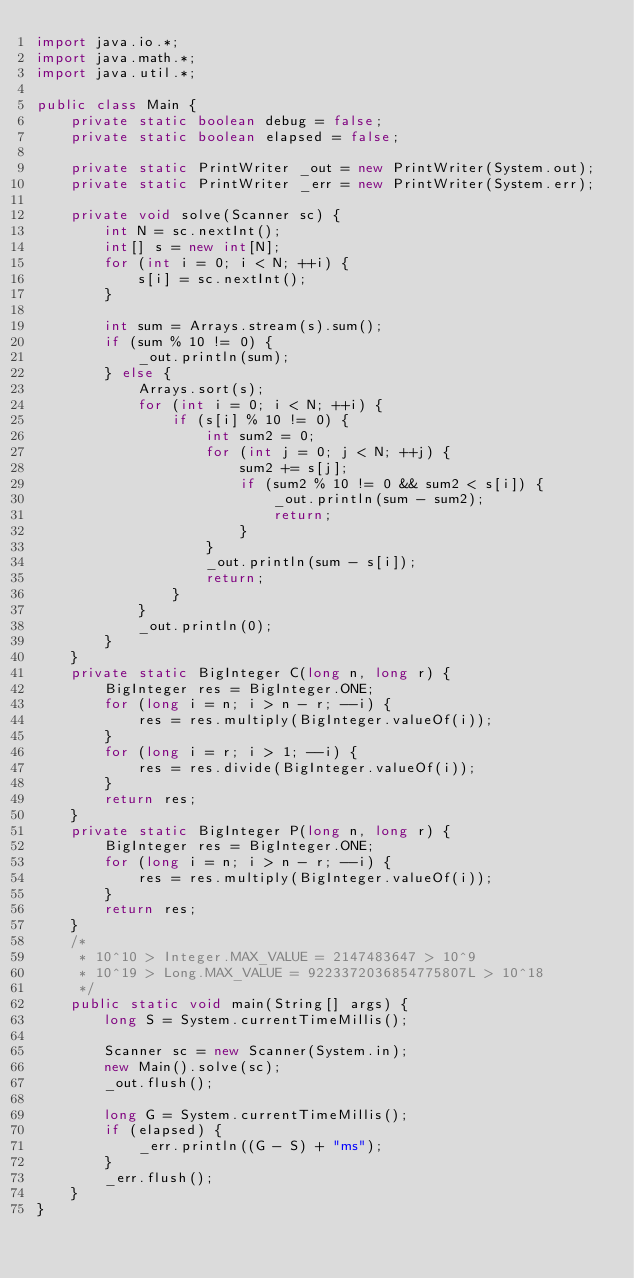<code> <loc_0><loc_0><loc_500><loc_500><_Java_>import java.io.*;
import java.math.*;
import java.util.*;

public class Main {
    private static boolean debug = false;
    private static boolean elapsed = false;

    private static PrintWriter _out = new PrintWriter(System.out);
    private static PrintWriter _err = new PrintWriter(System.err);

    private void solve(Scanner sc) {
        int N = sc.nextInt();
        int[] s = new int[N];
        for (int i = 0; i < N; ++i) {
            s[i] = sc.nextInt();
        }

        int sum = Arrays.stream(s).sum();
        if (sum % 10 != 0) {
            _out.println(sum);
        } else {
            Arrays.sort(s);
            for (int i = 0; i < N; ++i) {
                if (s[i] % 10 != 0) {
                    int sum2 = 0;
                    for (int j = 0; j < N; ++j) {
                        sum2 += s[j];
                        if (sum2 % 10 != 0 && sum2 < s[i]) {
                            _out.println(sum - sum2);
                            return;
                        }
                    }
                    _out.println(sum - s[i]);
                    return;
                }
            }
            _out.println(0);
        }
    }
    private static BigInteger C(long n, long r) {
        BigInteger res = BigInteger.ONE;
        for (long i = n; i > n - r; --i) {
            res = res.multiply(BigInteger.valueOf(i));
        }
        for (long i = r; i > 1; --i) {
            res = res.divide(BigInteger.valueOf(i));
        }
        return res;
    }
    private static BigInteger P(long n, long r) {
        BigInteger res = BigInteger.ONE;
        for (long i = n; i > n - r; --i) {
            res = res.multiply(BigInteger.valueOf(i));
        }
        return res;
    }
    /*
     * 10^10 > Integer.MAX_VALUE = 2147483647 > 10^9
     * 10^19 > Long.MAX_VALUE = 9223372036854775807L > 10^18
     */
    public static void main(String[] args) {
        long S = System.currentTimeMillis();

        Scanner sc = new Scanner(System.in);
        new Main().solve(sc);
        _out.flush();

        long G = System.currentTimeMillis();
        if (elapsed) {
            _err.println((G - S) + "ms");
        }
        _err.flush();
    }
}</code> 